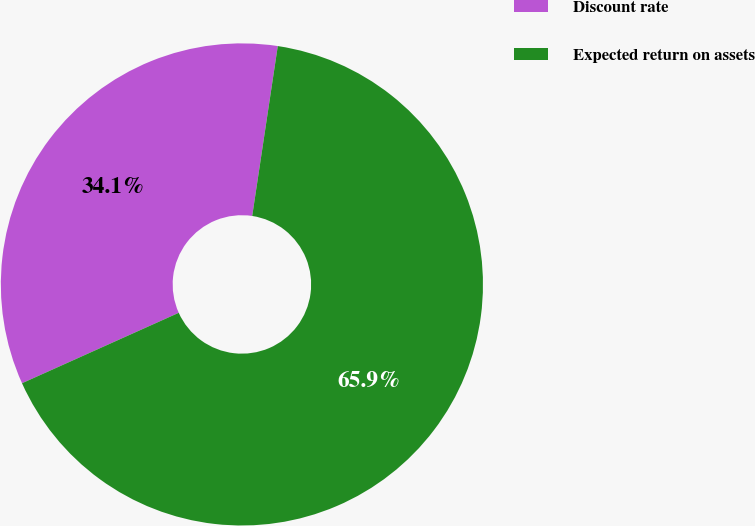Convert chart to OTSL. <chart><loc_0><loc_0><loc_500><loc_500><pie_chart><fcel>Discount rate<fcel>Expected return on assets<nl><fcel>34.1%<fcel>65.9%<nl></chart> 